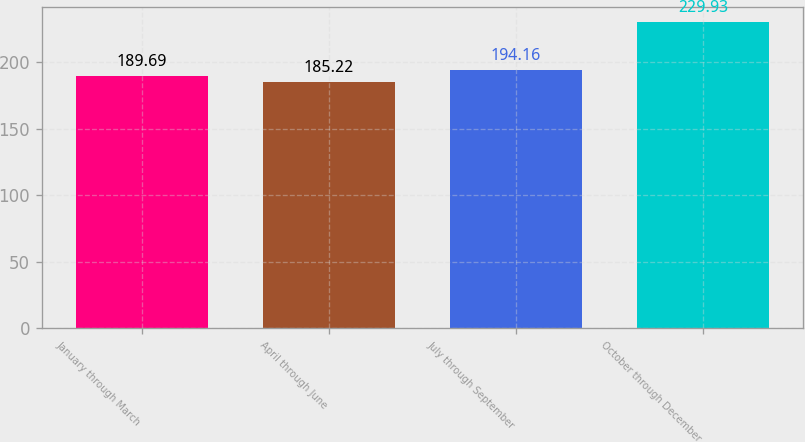Convert chart. <chart><loc_0><loc_0><loc_500><loc_500><bar_chart><fcel>January through March<fcel>April through June<fcel>July through September<fcel>October through December<nl><fcel>189.69<fcel>185.22<fcel>194.16<fcel>229.93<nl></chart> 